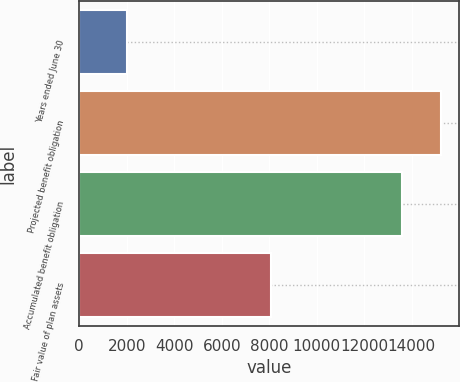Convert chart to OTSL. <chart><loc_0><loc_0><loc_500><loc_500><bar_chart><fcel>Years ended June 30<fcel>Projected benefit obligation<fcel>Accumulated benefit obligation<fcel>Fair value of plan assets<nl><fcel>2016<fcel>15233<fcel>13587<fcel>8082<nl></chart> 